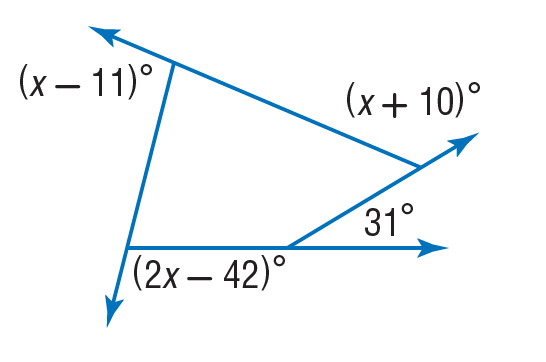Question: Find the value of x in the diagram.
Choices:
A. 10
B. 11
C. 31
D. 93
Answer with the letter. Answer: D 